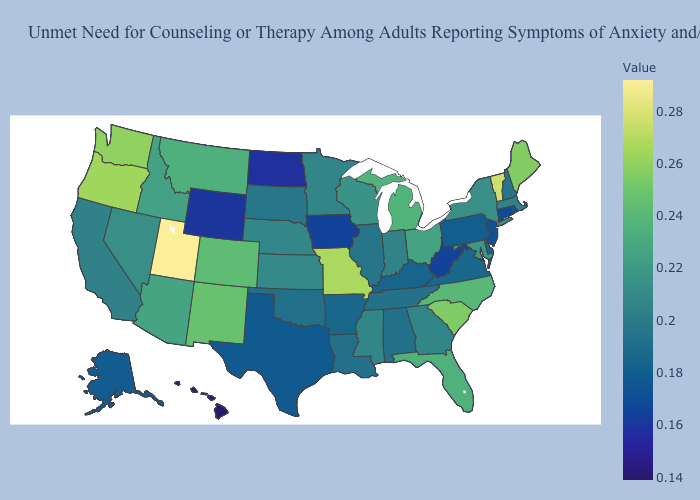Does North Dakota have the lowest value in the MidWest?
Write a very short answer. Yes. Which states have the lowest value in the USA?
Keep it brief. Hawaii. Does Kentucky have the lowest value in the South?
Quick response, please. No. Does Oklahoma have a higher value than Wyoming?
Short answer required. Yes. Among the states that border Michigan , which have the lowest value?
Give a very brief answer. Indiana. Does Michigan have the highest value in the USA?
Be succinct. No. Does Hawaii have the lowest value in the USA?
Short answer required. Yes. Does South Dakota have the lowest value in the MidWest?
Answer briefly. No. 